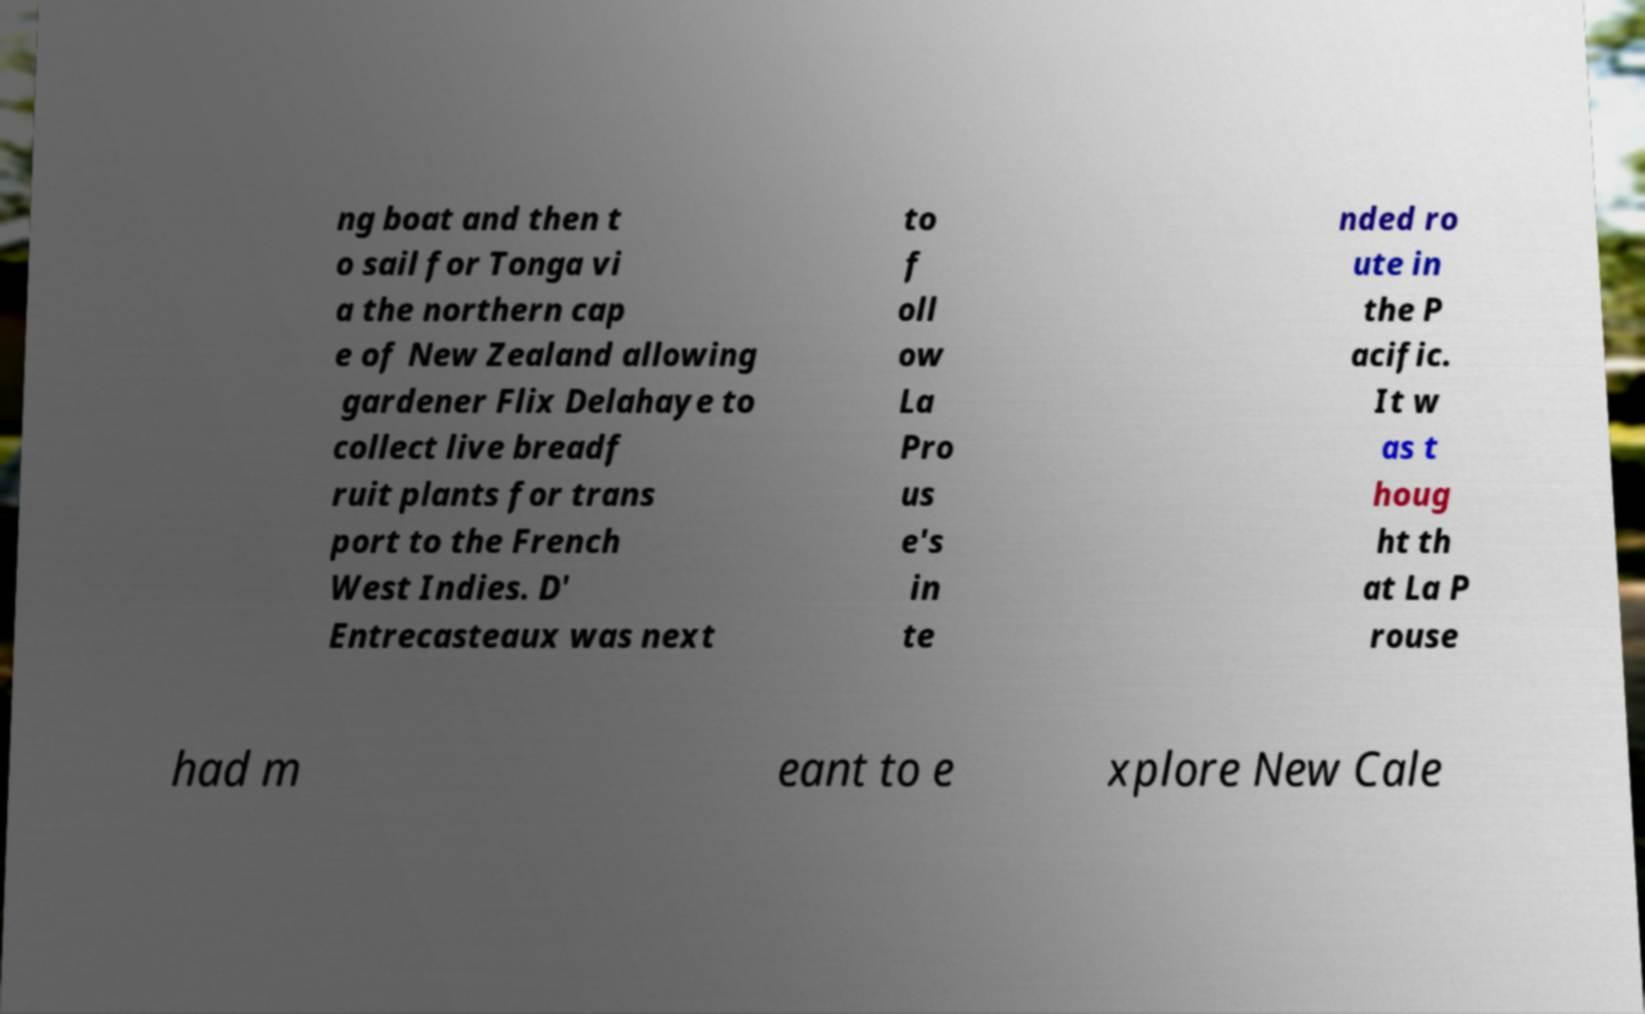For documentation purposes, I need the text within this image transcribed. Could you provide that? ng boat and then t o sail for Tonga vi a the northern cap e of New Zealand allowing gardener Flix Delahaye to collect live breadf ruit plants for trans port to the French West Indies. D' Entrecasteaux was next to f oll ow La Pro us e's in te nded ro ute in the P acific. It w as t houg ht th at La P rouse had m eant to e xplore New Cale 